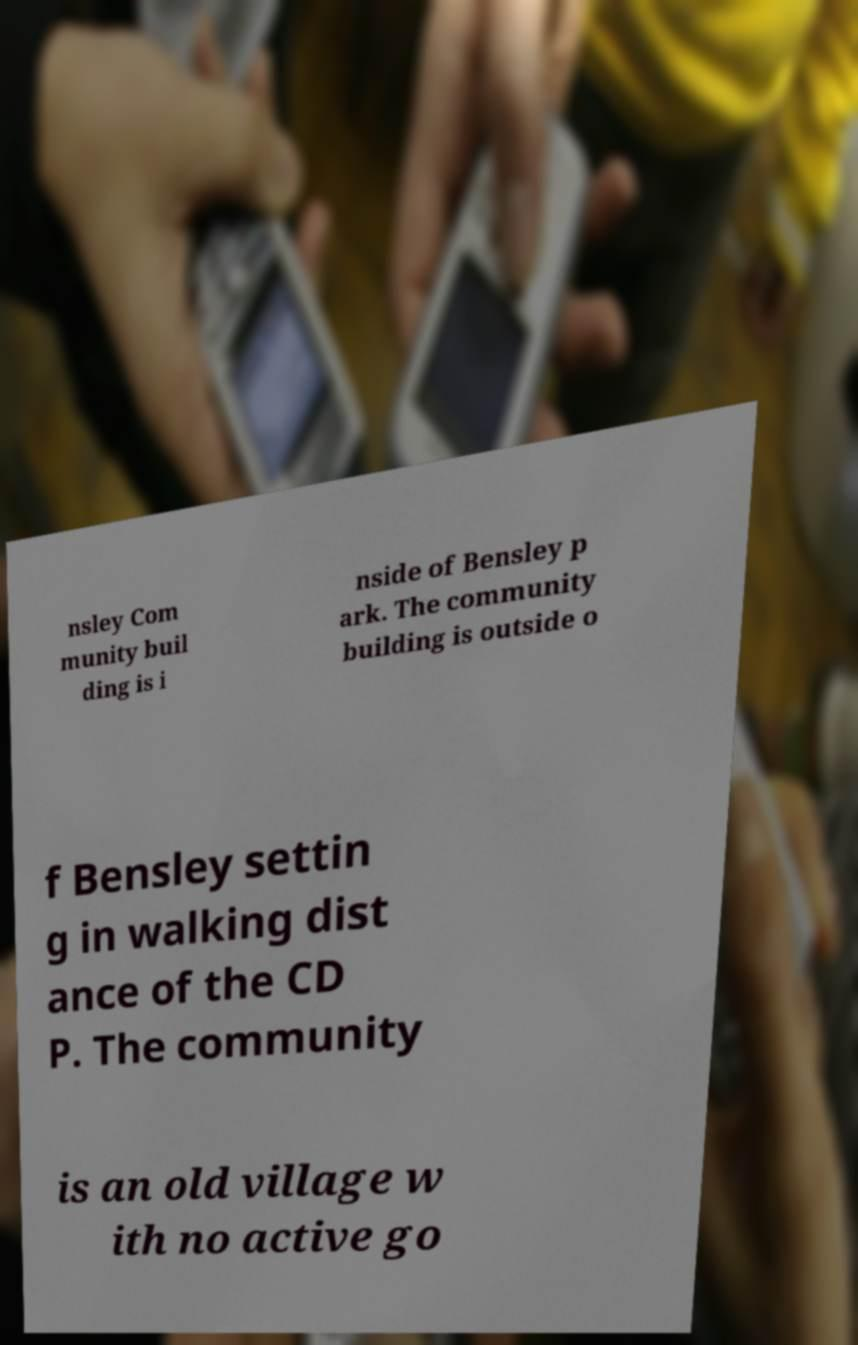Could you assist in decoding the text presented in this image and type it out clearly? nsley Com munity buil ding is i nside of Bensley p ark. The community building is outside o f Bensley settin g in walking dist ance of the CD P. The community is an old village w ith no active go 